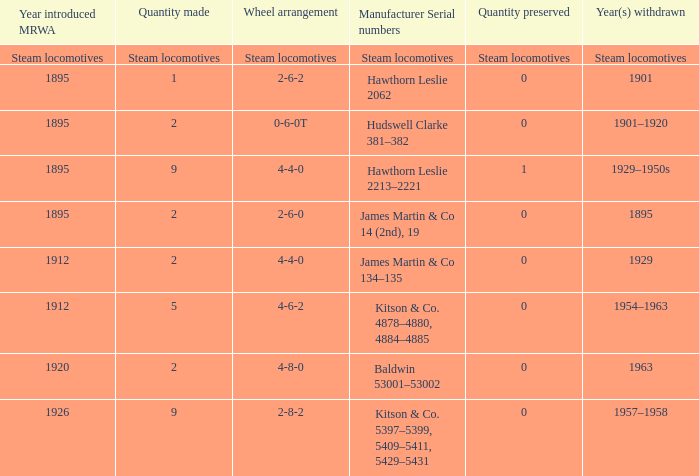What is the manufacturer serial number of the 1963 withdrawn year? Baldwin 53001–53002. 